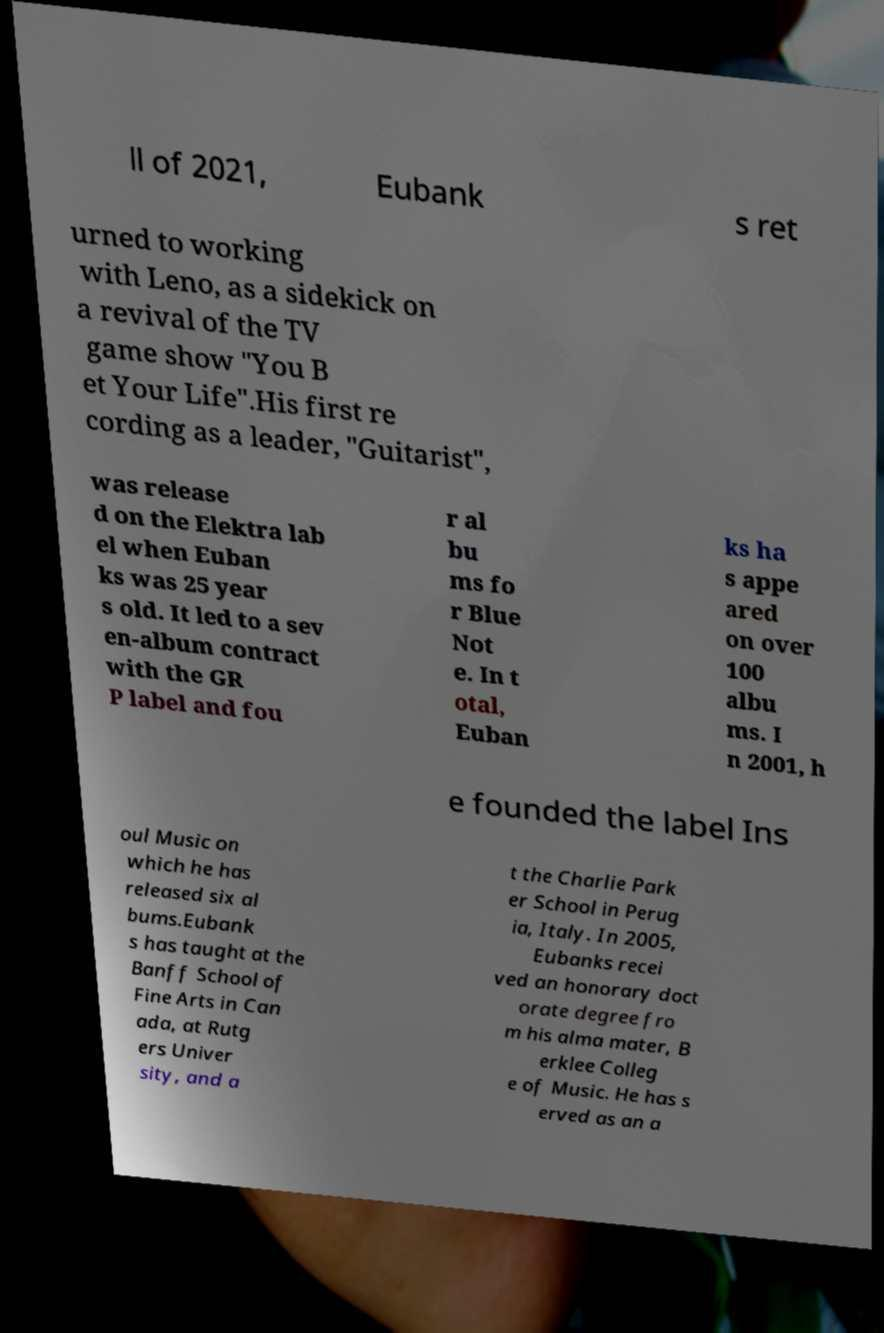There's text embedded in this image that I need extracted. Can you transcribe it verbatim? ll of 2021, Eubank s ret urned to working with Leno, as a sidekick on a revival of the TV game show "You B et Your Life".His first re cording as a leader, "Guitarist", was release d on the Elektra lab el when Euban ks was 25 year s old. It led to a sev en-album contract with the GR P label and fou r al bu ms fo r Blue Not e. In t otal, Euban ks ha s appe ared on over 100 albu ms. I n 2001, h e founded the label Ins oul Music on which he has released six al bums.Eubank s has taught at the Banff School of Fine Arts in Can ada, at Rutg ers Univer sity, and a t the Charlie Park er School in Perug ia, Italy. In 2005, Eubanks recei ved an honorary doct orate degree fro m his alma mater, B erklee Colleg e of Music. He has s erved as an a 